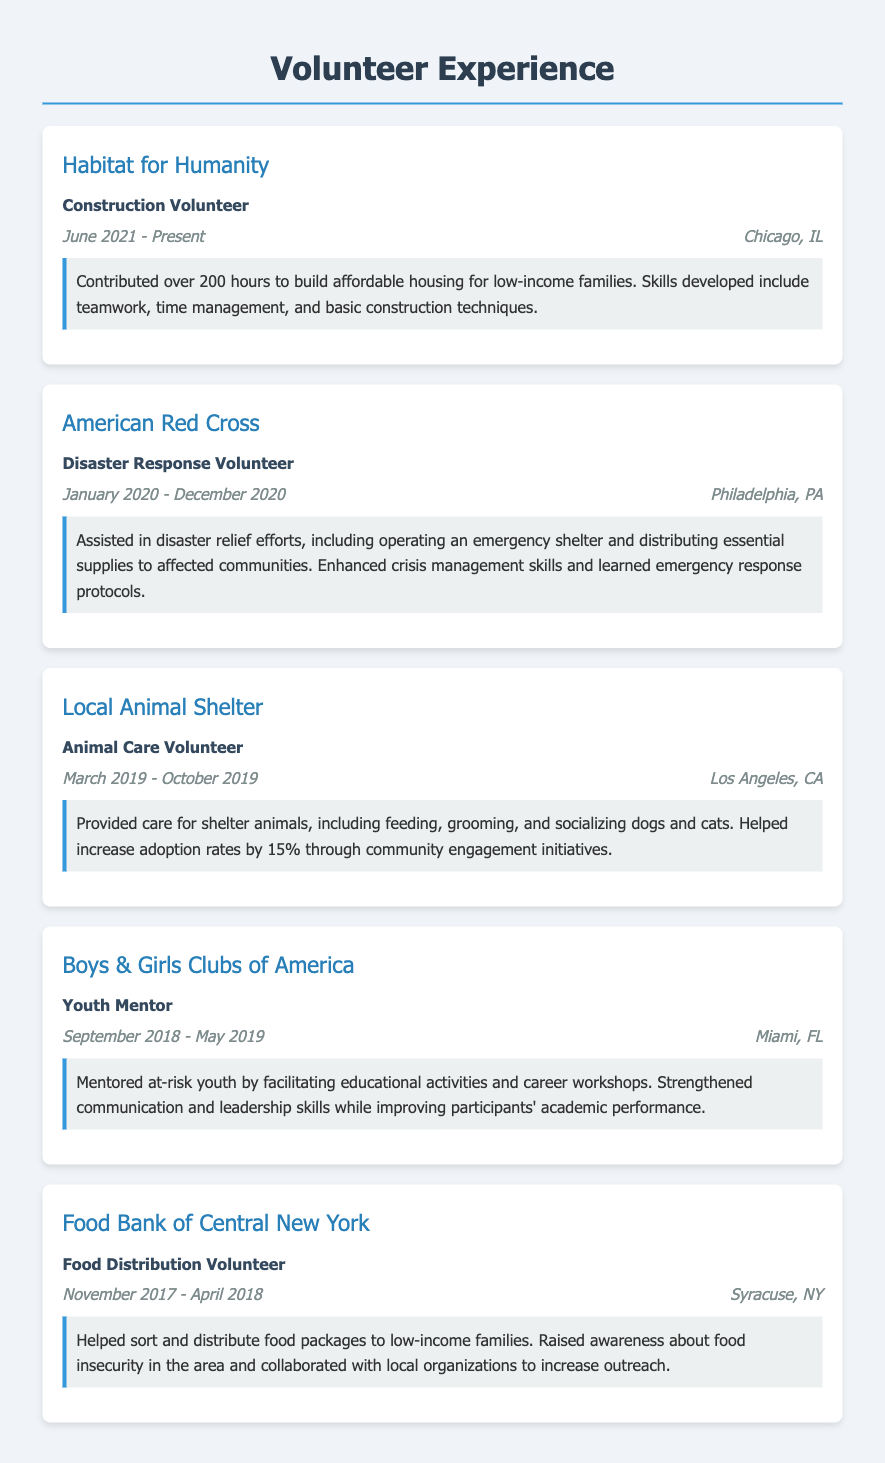What organization did the volunteer build houses for? The organization where the volunteer contributed to building affordable housing is Habitat for Humanity.
Answer: Habitat for Humanity What role did the volunteer serve at the American Red Cross? The volunteer served as a Disaster Response Volunteer at the American Red Cross.
Answer: Disaster Response Volunteer How many hours did the volunteer contribute to Habitat for Humanity? The volunteer contributed over 200 hours to Habitat for Humanity.
Answer: 200 hours In which city did the volunteer serve as an Animal Care Volunteer? The volunteer served as an Animal Care Volunteer at the Local Animal Shelter in Los Angeles, CA.
Answer: Los Angeles, CA What was one of the impacts of mentoring at-risk youth? One of the impacts of mentoring at-risk youth was improving participants' academic performance.
Answer: Improving participants' academic performance When did the volunteer work at the Food Bank of Central New York? The volunteer worked at the Food Bank of Central New York from November 2017 to April 2018.
Answer: November 2017 - April 2018 What type of volunteer work included operating an emergency shelter? The volunteer work that involved operating an emergency shelter was as a Disaster Response Volunteer.
Answer: Disaster Response Volunteer Which organization helped increase adoption rates by 15%? The organization that helped increase adoption rates by 15% is Local Animal Shelter.
Answer: Local Animal Shelter What skill was developed while volunteering at Habitat for Humanity? While volunteering at Habitat for Humanity, skills developed included teamwork.
Answer: Teamwork 